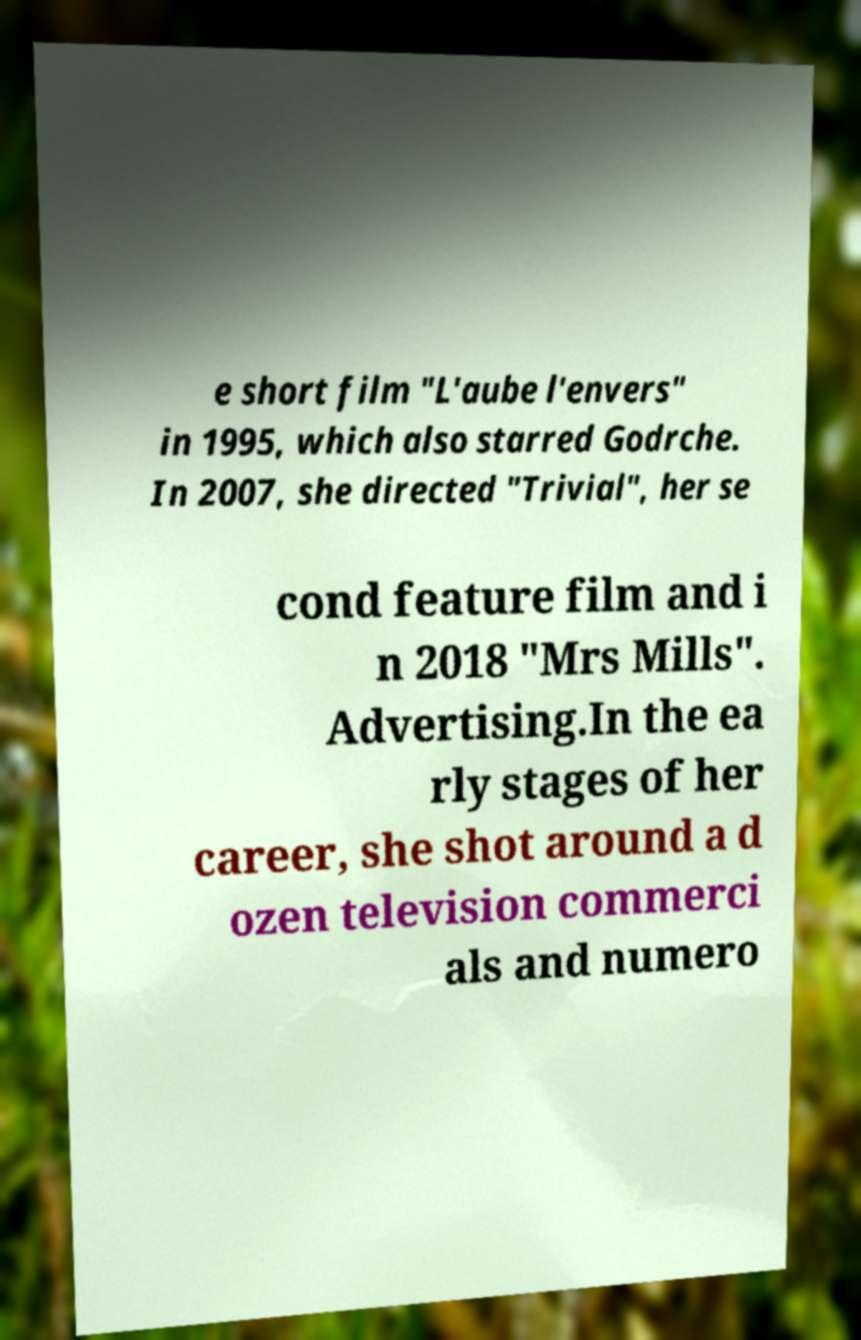Please identify and transcribe the text found in this image. e short film "L'aube l'envers" in 1995, which also starred Godrche. In 2007, she directed "Trivial", her se cond feature film and i n 2018 "Mrs Mills". Advertising.In the ea rly stages of her career, she shot around a d ozen television commerci als and numero 